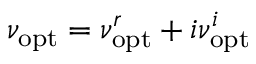Convert formula to latex. <formula><loc_0><loc_0><loc_500><loc_500>\nu _ { o p t } = \nu _ { o p t } ^ { r } + i \nu _ { o p t } ^ { i }</formula> 